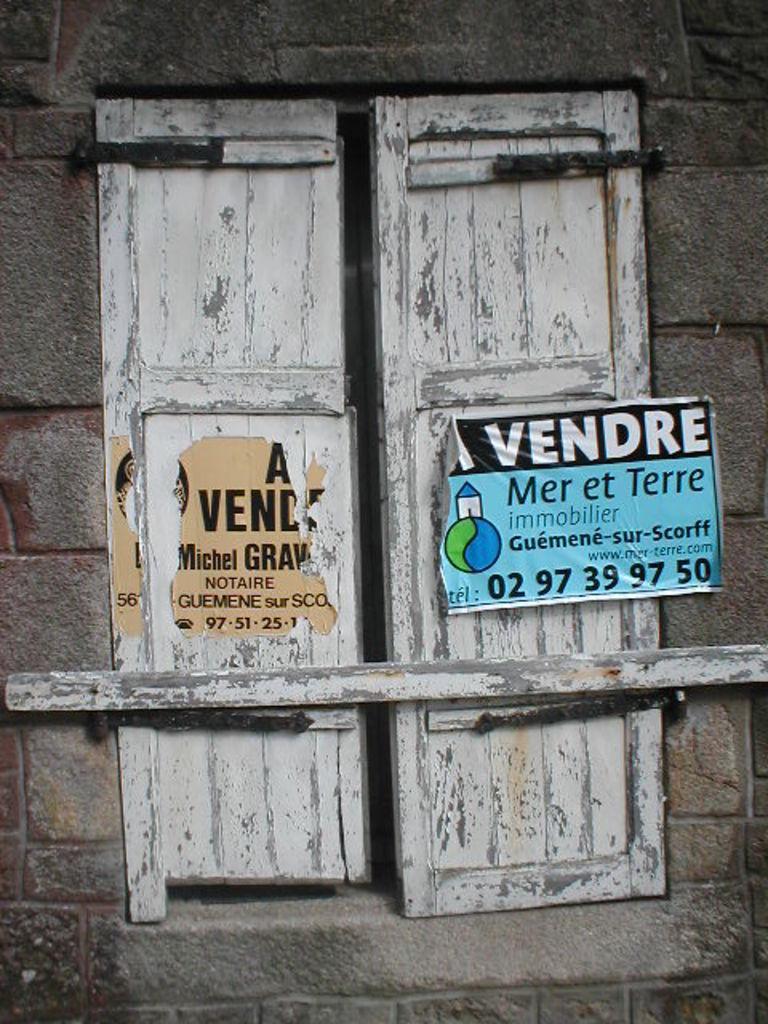Please provide a concise description of this image. In this image we can see a wall with window and poster. 